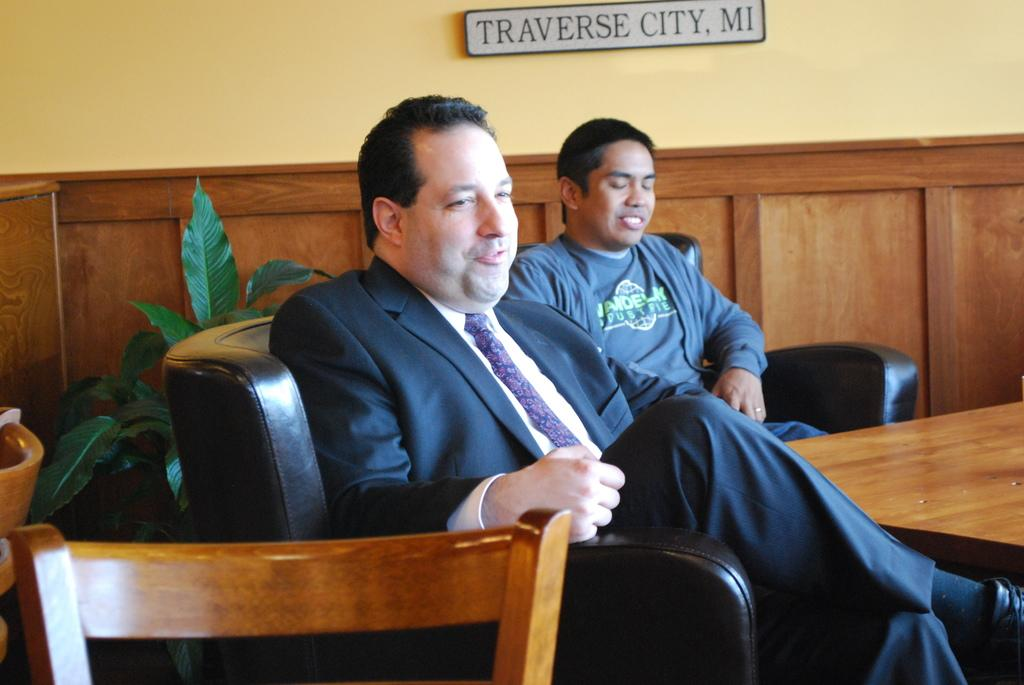How many people are in the image? There are two persons in the image. What are the two persons doing in the image? The two persons are sitting on a chair. What is in front of the two persons? There is a table in front of the two persons. What is the income of the ants crawling on the table in the image? There are no ants present in the image, so it is not possible to determine their income. 